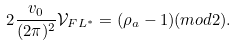Convert formula to latex. <formula><loc_0><loc_0><loc_500><loc_500>2 \frac { v _ { 0 } } { ( 2 \pi ) ^ { 2 } } \mathcal { V } _ { F L ^ { * } } = ( \rho _ { a } - 1 ) ( m o d 2 ) .</formula> 